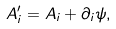Convert formula to latex. <formula><loc_0><loc_0><loc_500><loc_500>A ^ { \prime } _ { i } = A _ { i } + \partial _ { i } \psi ,</formula> 